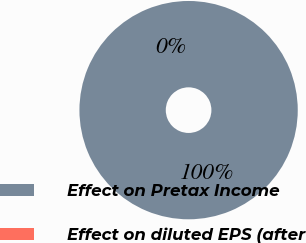<chart> <loc_0><loc_0><loc_500><loc_500><pie_chart><fcel>Effect on Pretax Income<fcel>Effect on diluted EPS (after<nl><fcel>100.0%<fcel>0.0%<nl></chart> 